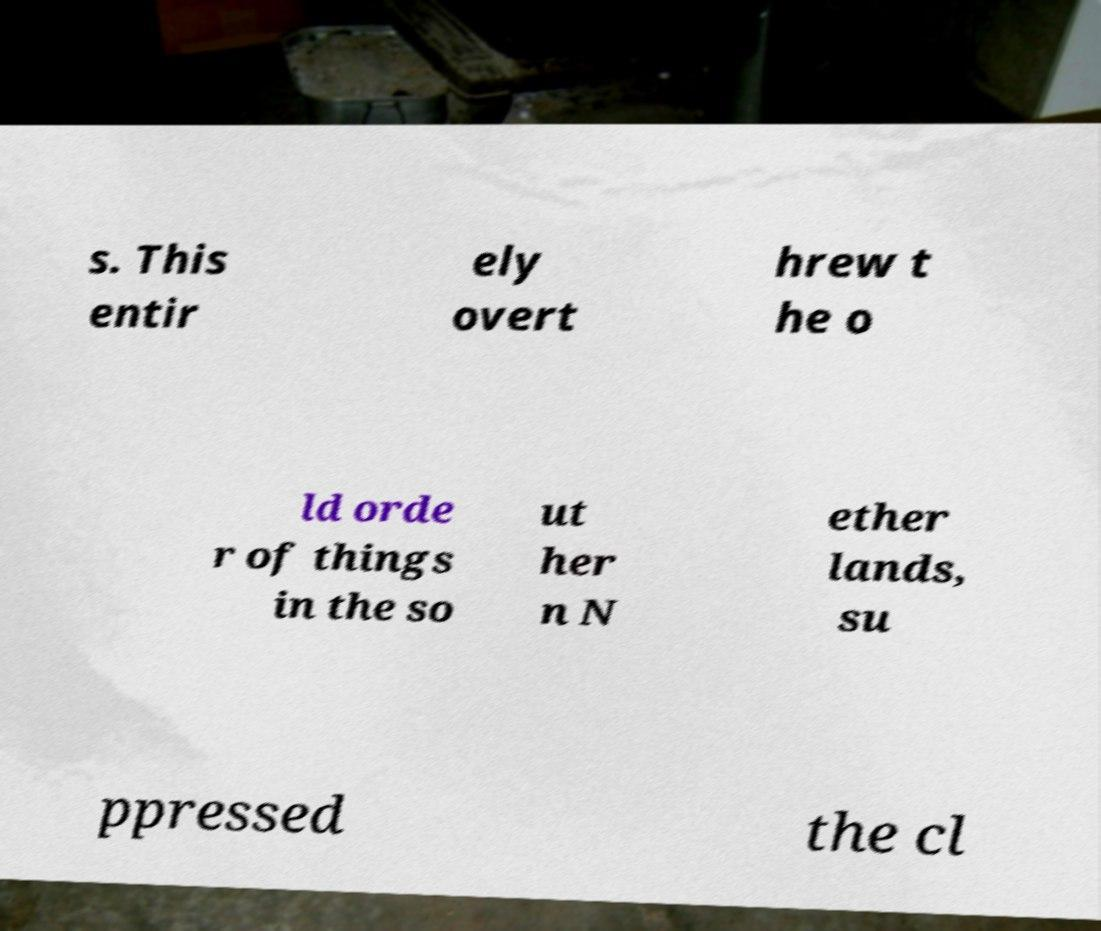Could you assist in decoding the text presented in this image and type it out clearly? s. This entir ely overt hrew t he o ld orde r of things in the so ut her n N ether lands, su ppressed the cl 